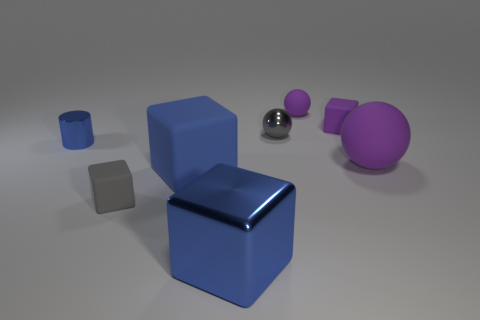What number of other objects are the same color as the large metallic object?
Offer a very short reply. 2. What is the small gray cube made of?
Your answer should be compact. Rubber. There is a blue shiny object that is on the right side of the gray matte cube; is it the same size as the blue metal cylinder?
Your answer should be very brief. No. Is there anything else that is the same size as the gray matte cube?
Your answer should be very brief. Yes. What is the size of the purple rubber object that is the same shape as the blue matte object?
Your response must be concise. Small. Are there an equal number of purple balls behind the tiny matte sphere and gray matte blocks that are right of the big sphere?
Keep it short and to the point. Yes. What size is the gray matte object to the right of the small blue cylinder?
Offer a terse response. Small. Does the metallic block have the same color as the small metallic cylinder?
Keep it short and to the point. Yes. Is there any other thing that has the same shape as the big metal object?
Your response must be concise. Yes. What is the material of the tiny object that is the same color as the large metallic cube?
Your response must be concise. Metal. 